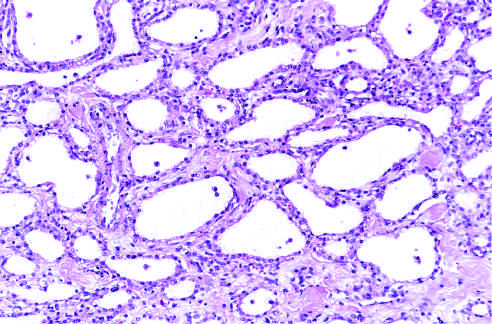what are the cysts lined by?
Answer the question using a single word or phrase. Cuboidal epithelium without atypia 